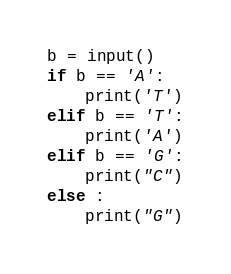<code> <loc_0><loc_0><loc_500><loc_500><_Python_>b = input()
if b == 'A':
    print('T')
elif b == 'T':
    print('A')
elif b == 'G':
    print("C")
else :
    print("G")</code> 